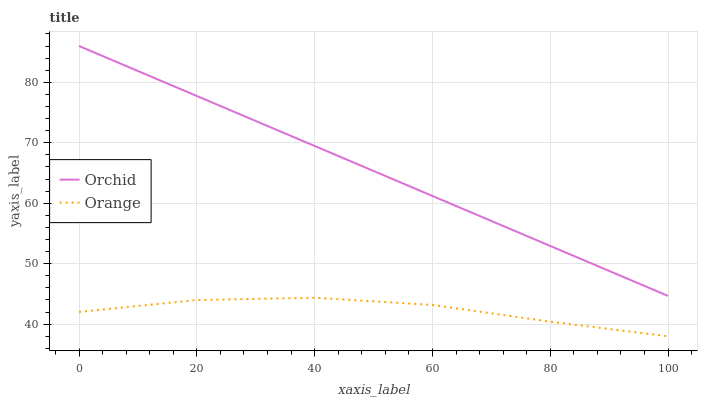Does Orange have the minimum area under the curve?
Answer yes or no. Yes. Does Orchid have the maximum area under the curve?
Answer yes or no. Yes. Does Orchid have the minimum area under the curve?
Answer yes or no. No. Is Orchid the smoothest?
Answer yes or no. Yes. Is Orange the roughest?
Answer yes or no. Yes. Is Orchid the roughest?
Answer yes or no. No. Does Orchid have the lowest value?
Answer yes or no. No. Does Orchid have the highest value?
Answer yes or no. Yes. Is Orange less than Orchid?
Answer yes or no. Yes. Is Orchid greater than Orange?
Answer yes or no. Yes. Does Orange intersect Orchid?
Answer yes or no. No. 